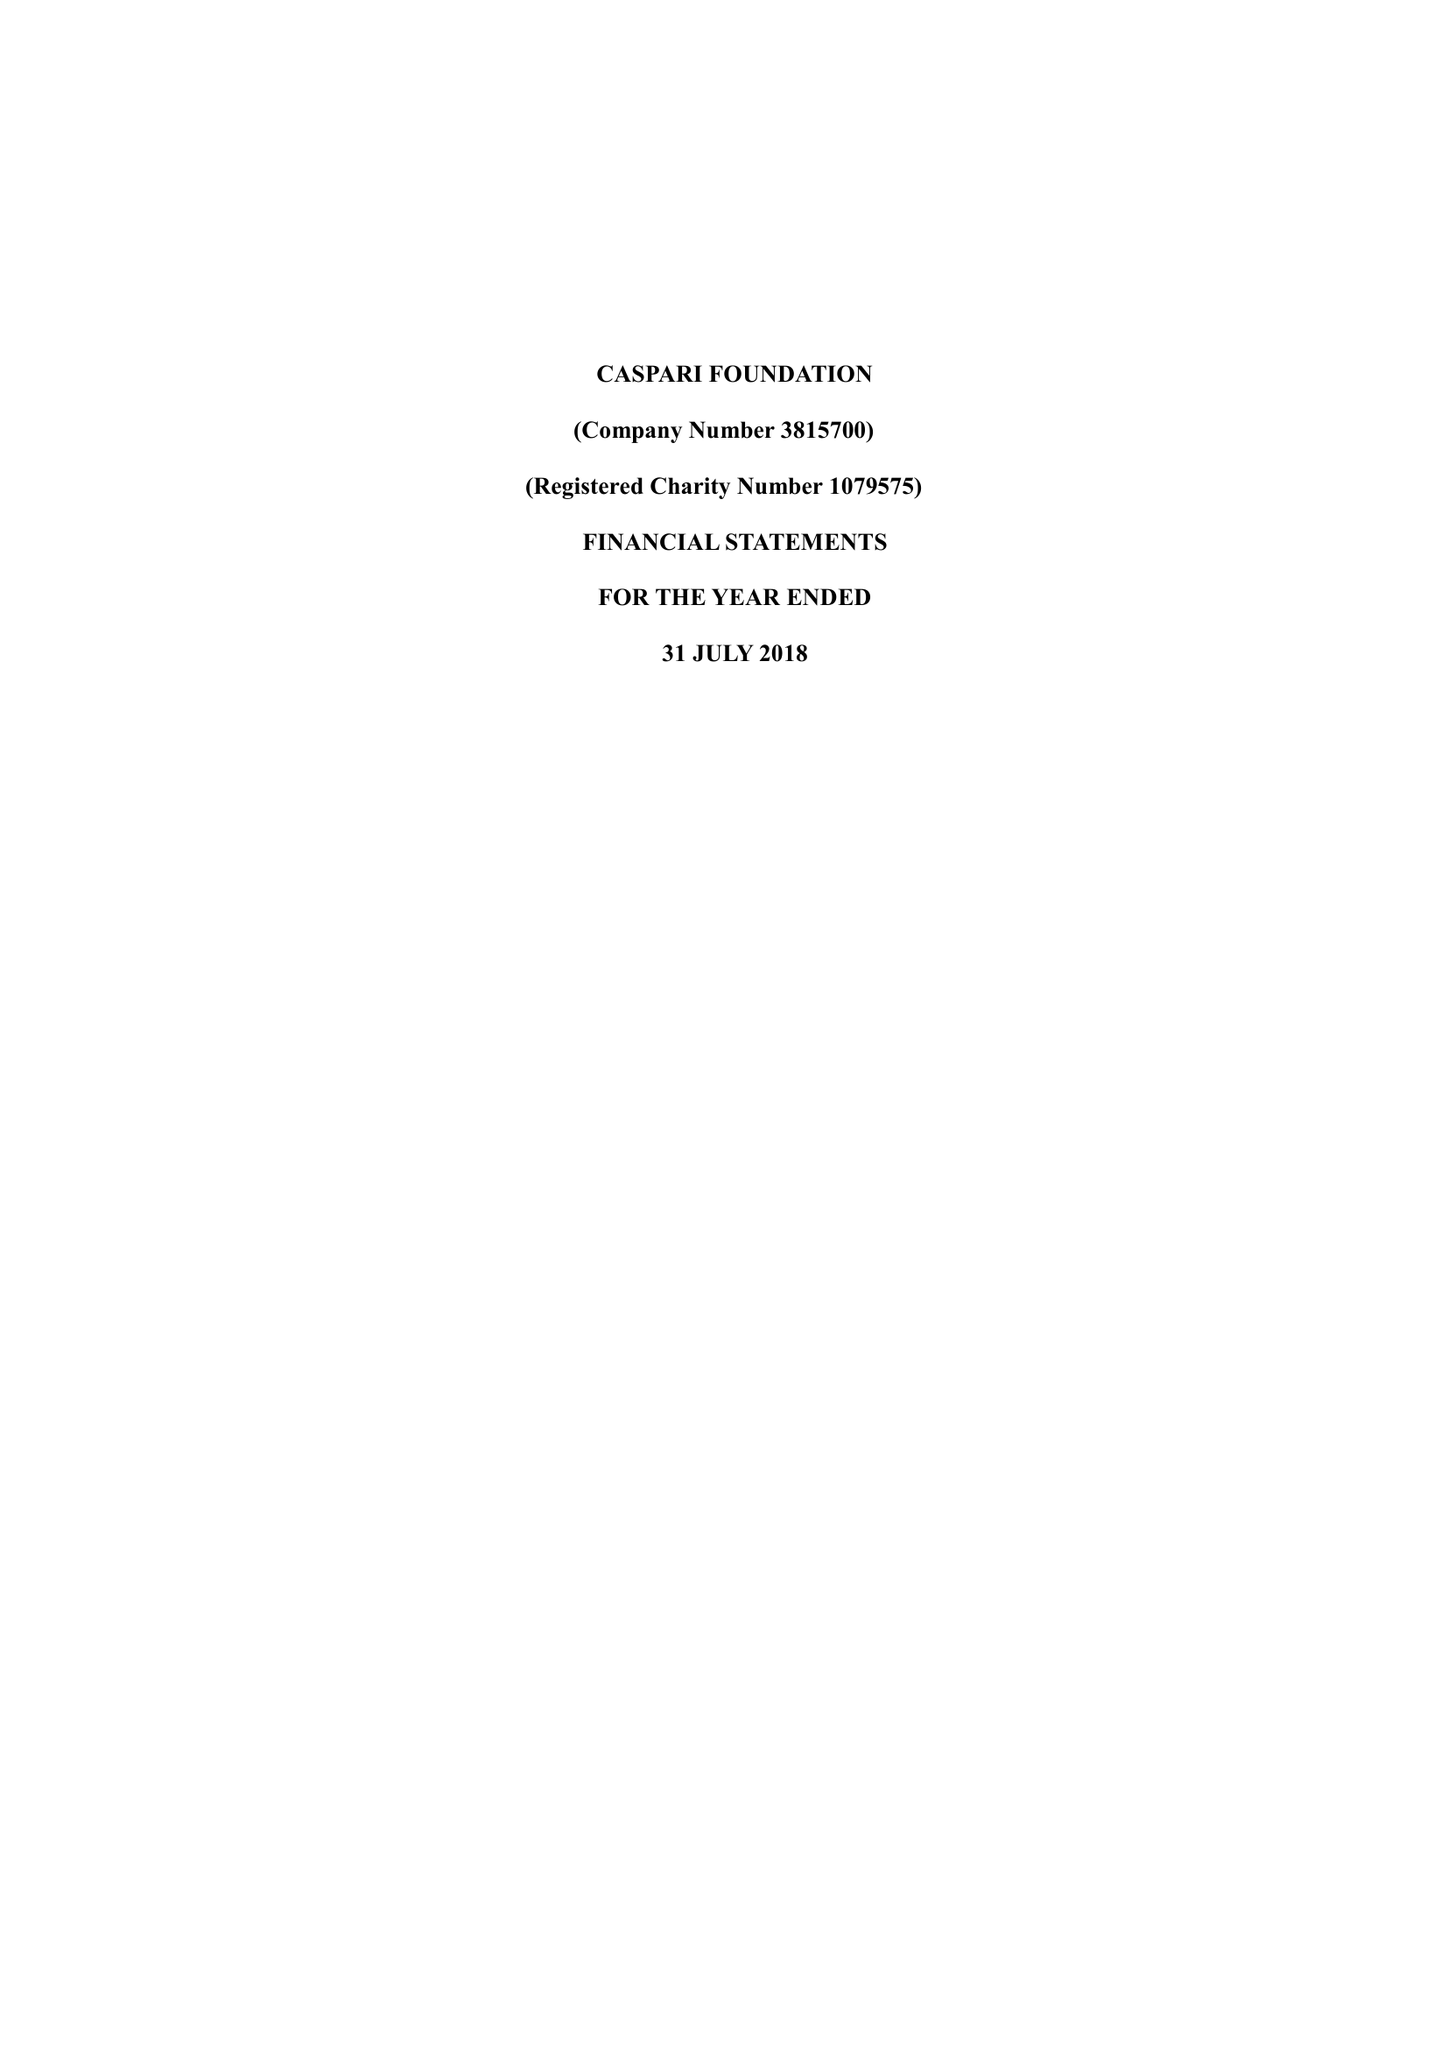What is the value for the income_annually_in_british_pounds?
Answer the question using a single word or phrase. 200098.00 